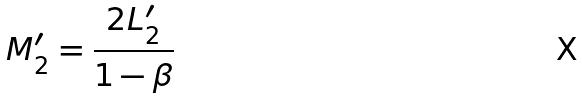<formula> <loc_0><loc_0><loc_500><loc_500>M _ { 2 } ^ { \prime } = \frac { 2 L _ { 2 } ^ { \prime } } { 1 - \beta }</formula> 